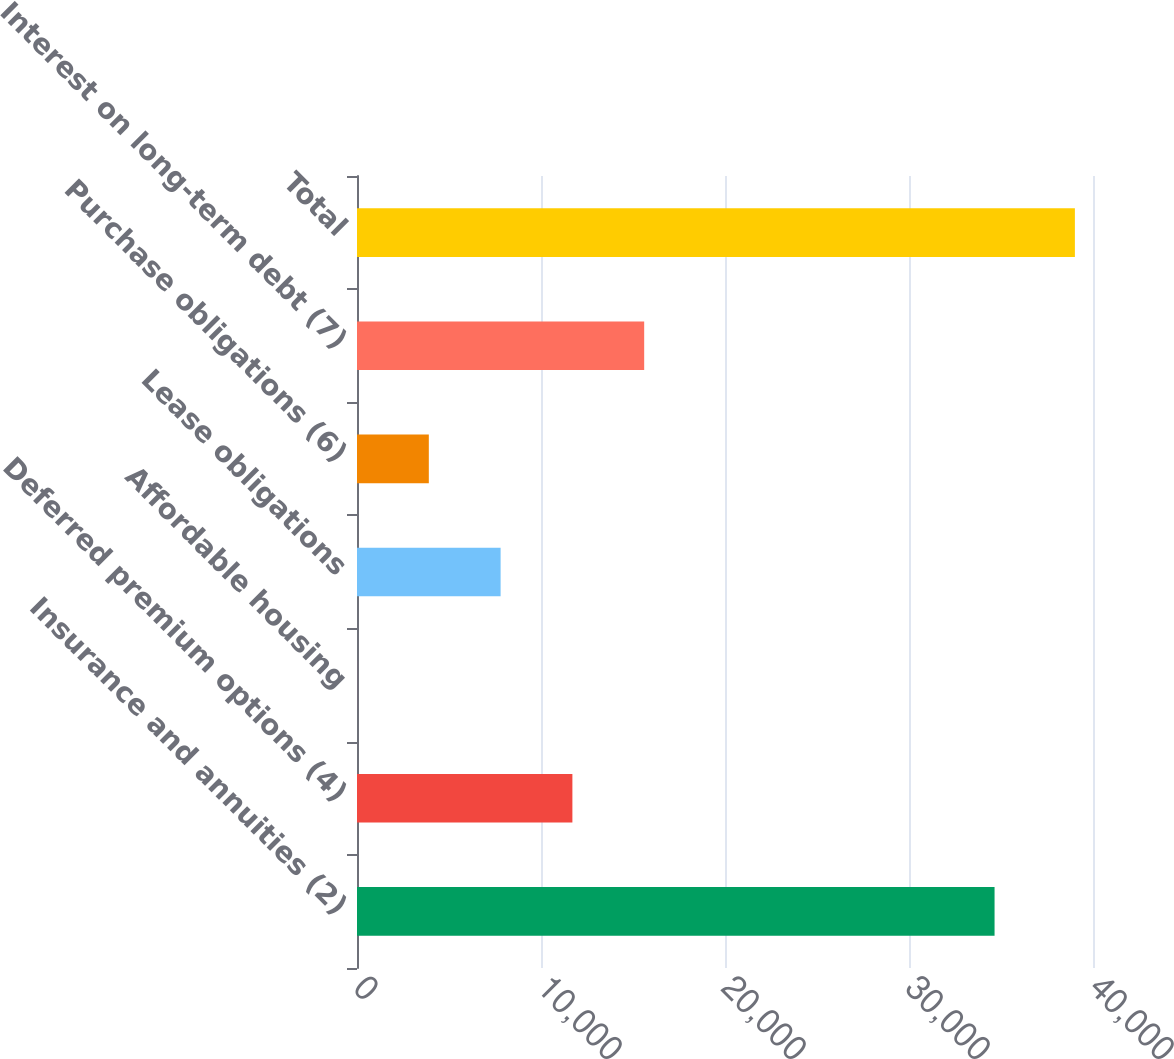Convert chart to OTSL. <chart><loc_0><loc_0><loc_500><loc_500><bar_chart><fcel>Insurance and annuities (2)<fcel>Deferred premium options (4)<fcel>Affordable housing<fcel>Lease obligations<fcel>Purchase obligations (6)<fcel>Interest on long-term debt (7)<fcel>Total<nl><fcel>34650<fcel>11706.2<fcel>2<fcel>7804.8<fcel>3903.4<fcel>15607.6<fcel>39016<nl></chart> 